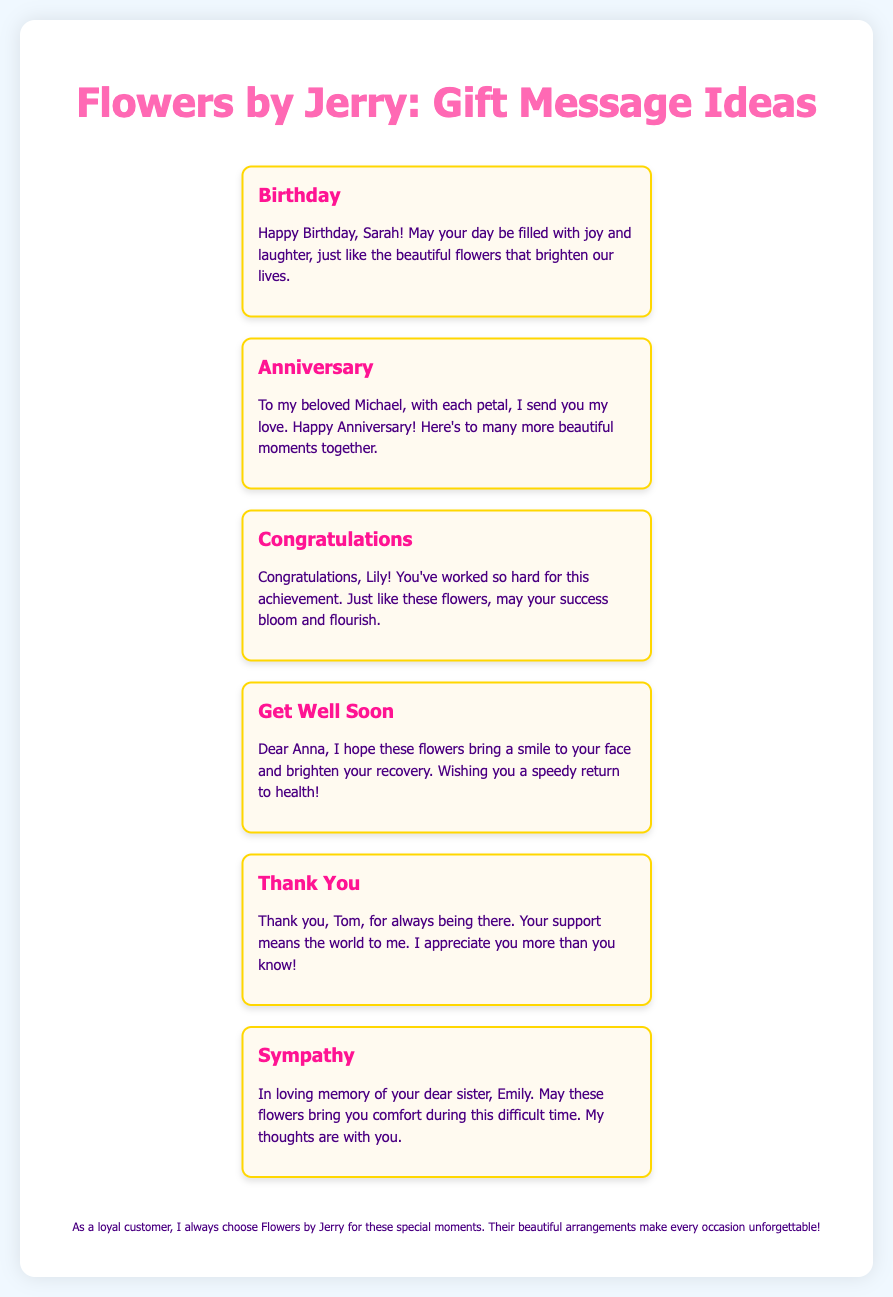What is the title of the document? The title appears prominently at the top of the document, which is "Flowers by Jerry - Gift Message Ideas."
Answer: Flowers by Jerry - Gift Message Ideas How many gift message ideas are provided? The document contains six different gift message ideas for various occasions.
Answer: Six Who is the message for the Birthday occasion? The Birthday message specifically addresses a person named Sarah.
Answer: Sarah What occasion is the message for Michael? The message for Michael is for an Anniversary occasion.
Answer: Anniversary What is the primary theme of the Sympathy message? The Sympathy message conveys comfort during a difficult time, specifically referencing the sender's thoughts for Emily's memory.
Answer: Comfort What is the color of the header text? The header text color is specified as #ff69b4, which is a shade of pink.
Answer: Pink 